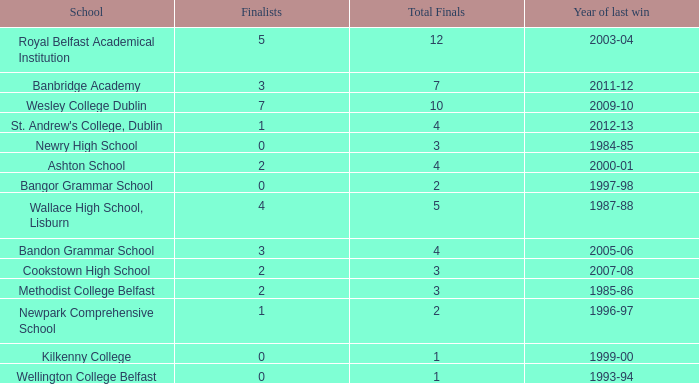Can you list the names with a finalist score of 2? Ashton School, Cookstown High School, Methodist College Belfast. 